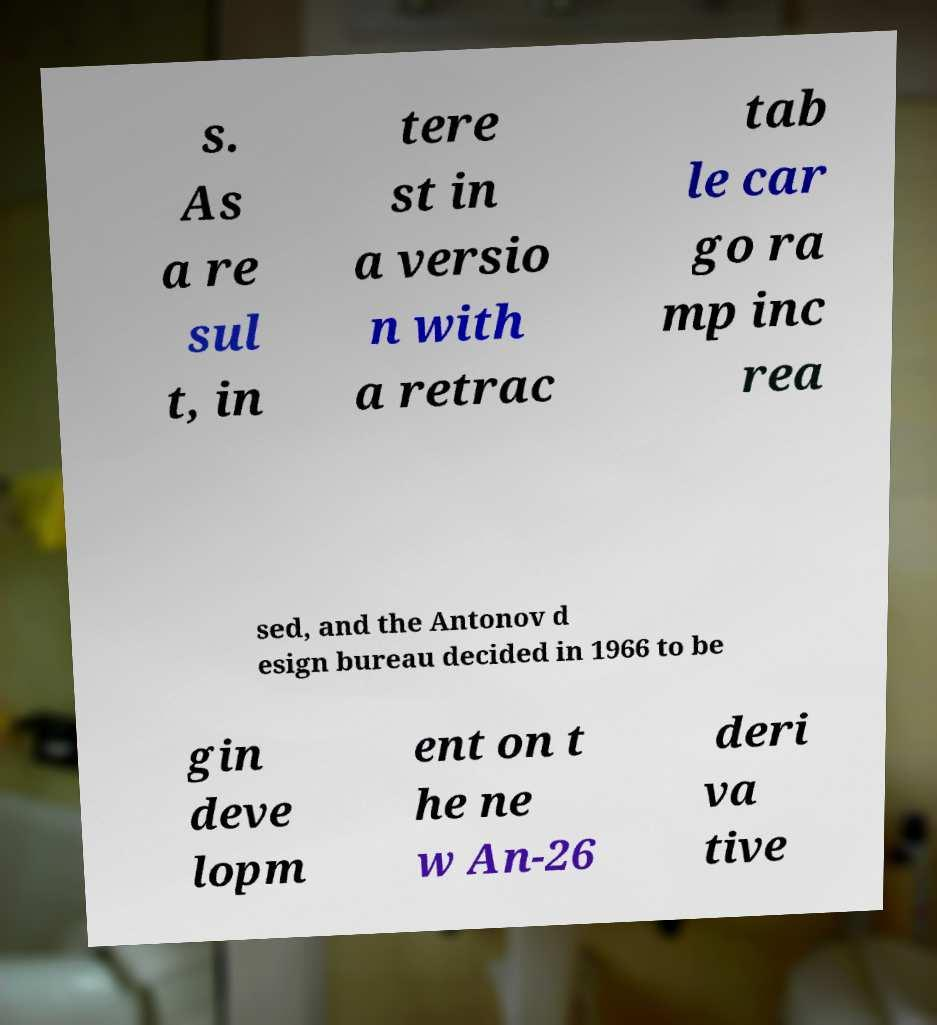Please identify and transcribe the text found in this image. s. As a re sul t, in tere st in a versio n with a retrac tab le car go ra mp inc rea sed, and the Antonov d esign bureau decided in 1966 to be gin deve lopm ent on t he ne w An-26 deri va tive 